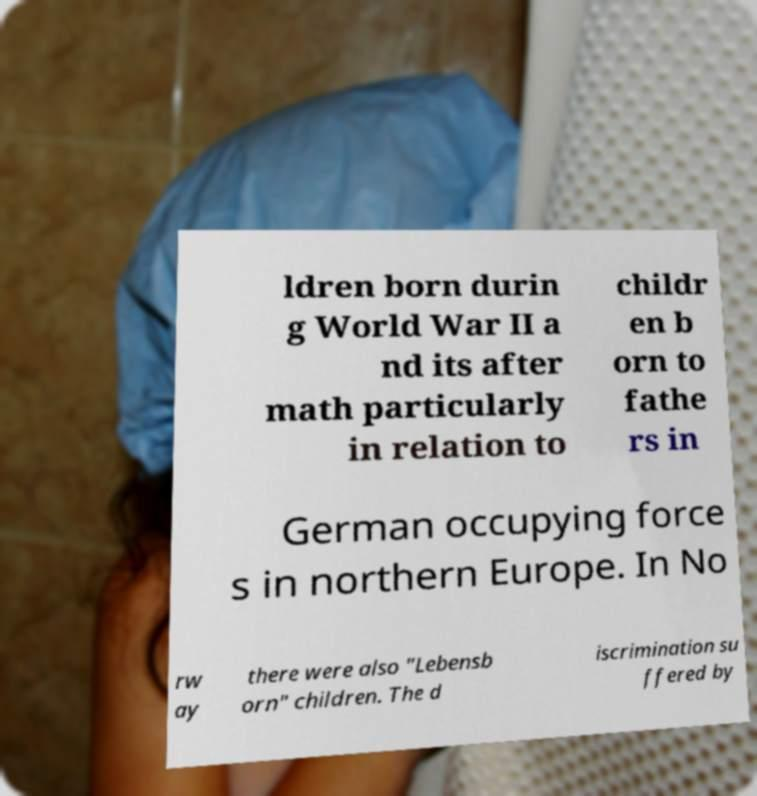Can you read and provide the text displayed in the image?This photo seems to have some interesting text. Can you extract and type it out for me? ldren born durin g World War II a nd its after math particularly in relation to childr en b orn to fathe rs in German occupying force s in northern Europe. In No rw ay there were also "Lebensb orn" children. The d iscrimination su ffered by 